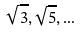Convert formula to latex. <formula><loc_0><loc_0><loc_500><loc_500>\sqrt { 3 } , \sqrt { 5 } , \dots</formula> 